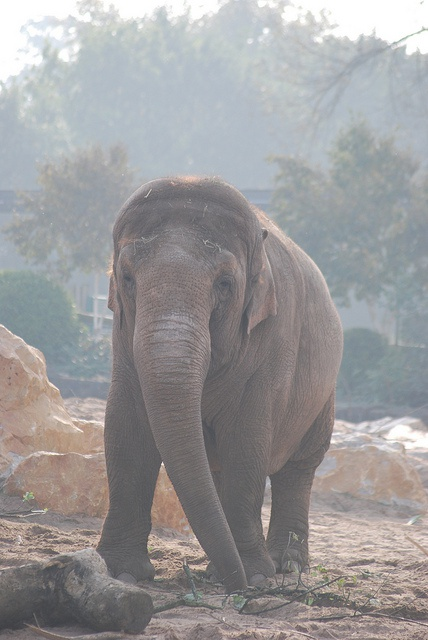Describe the objects in this image and their specific colors. I can see a elephant in white and gray tones in this image. 